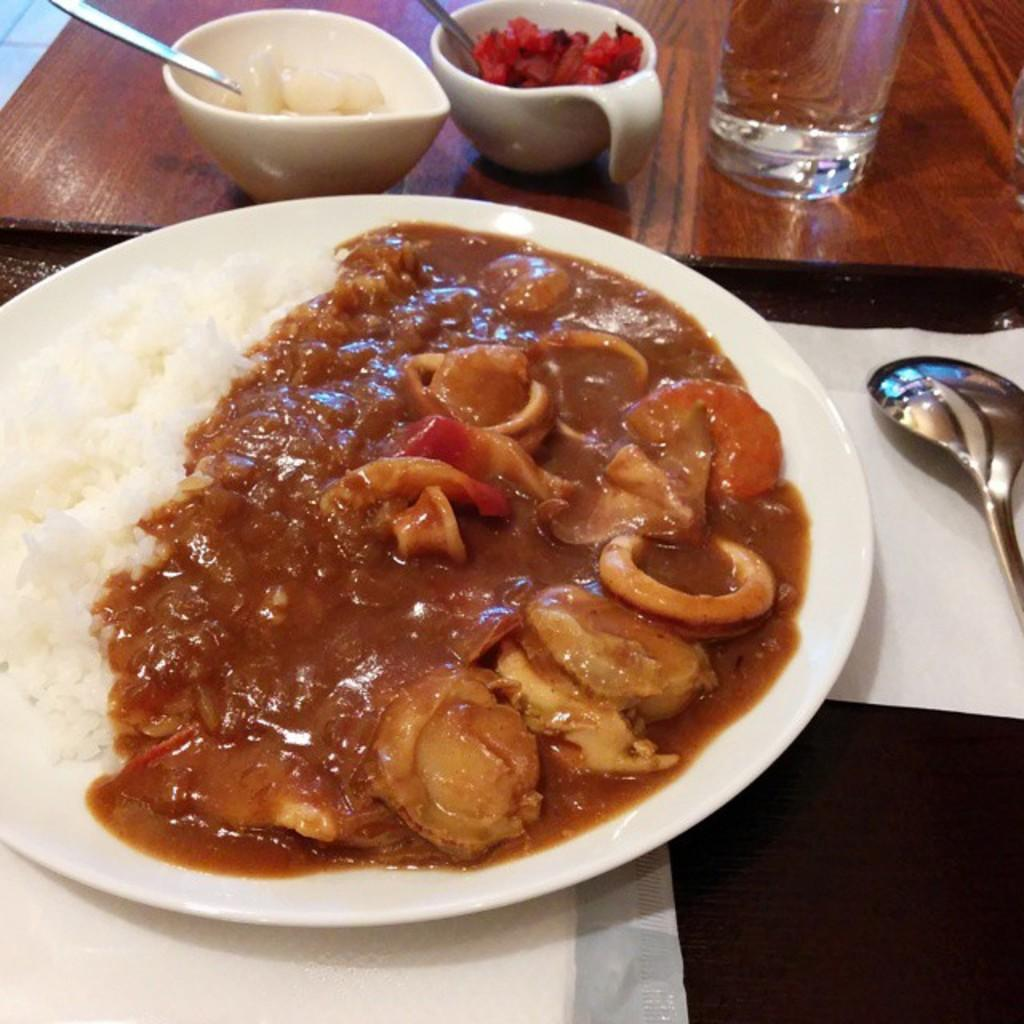What piece of furniture is present in the image? There is a table in the image. What is placed on the table? There are food items served in a plate, bowls, spoons, a glass, and tissue papers on the table. How many types of tableware are visible in the image? There are spoons and a glass visible in the image. What might be used for cleaning or wiping in the image? Tissue papers are present on the table for cleaning or wiping. What type of caption can be seen on the glass in the image? There is no caption present on the glass in the image. Can you see a snail crawling on the table in the image? There is no snail present in the image. 